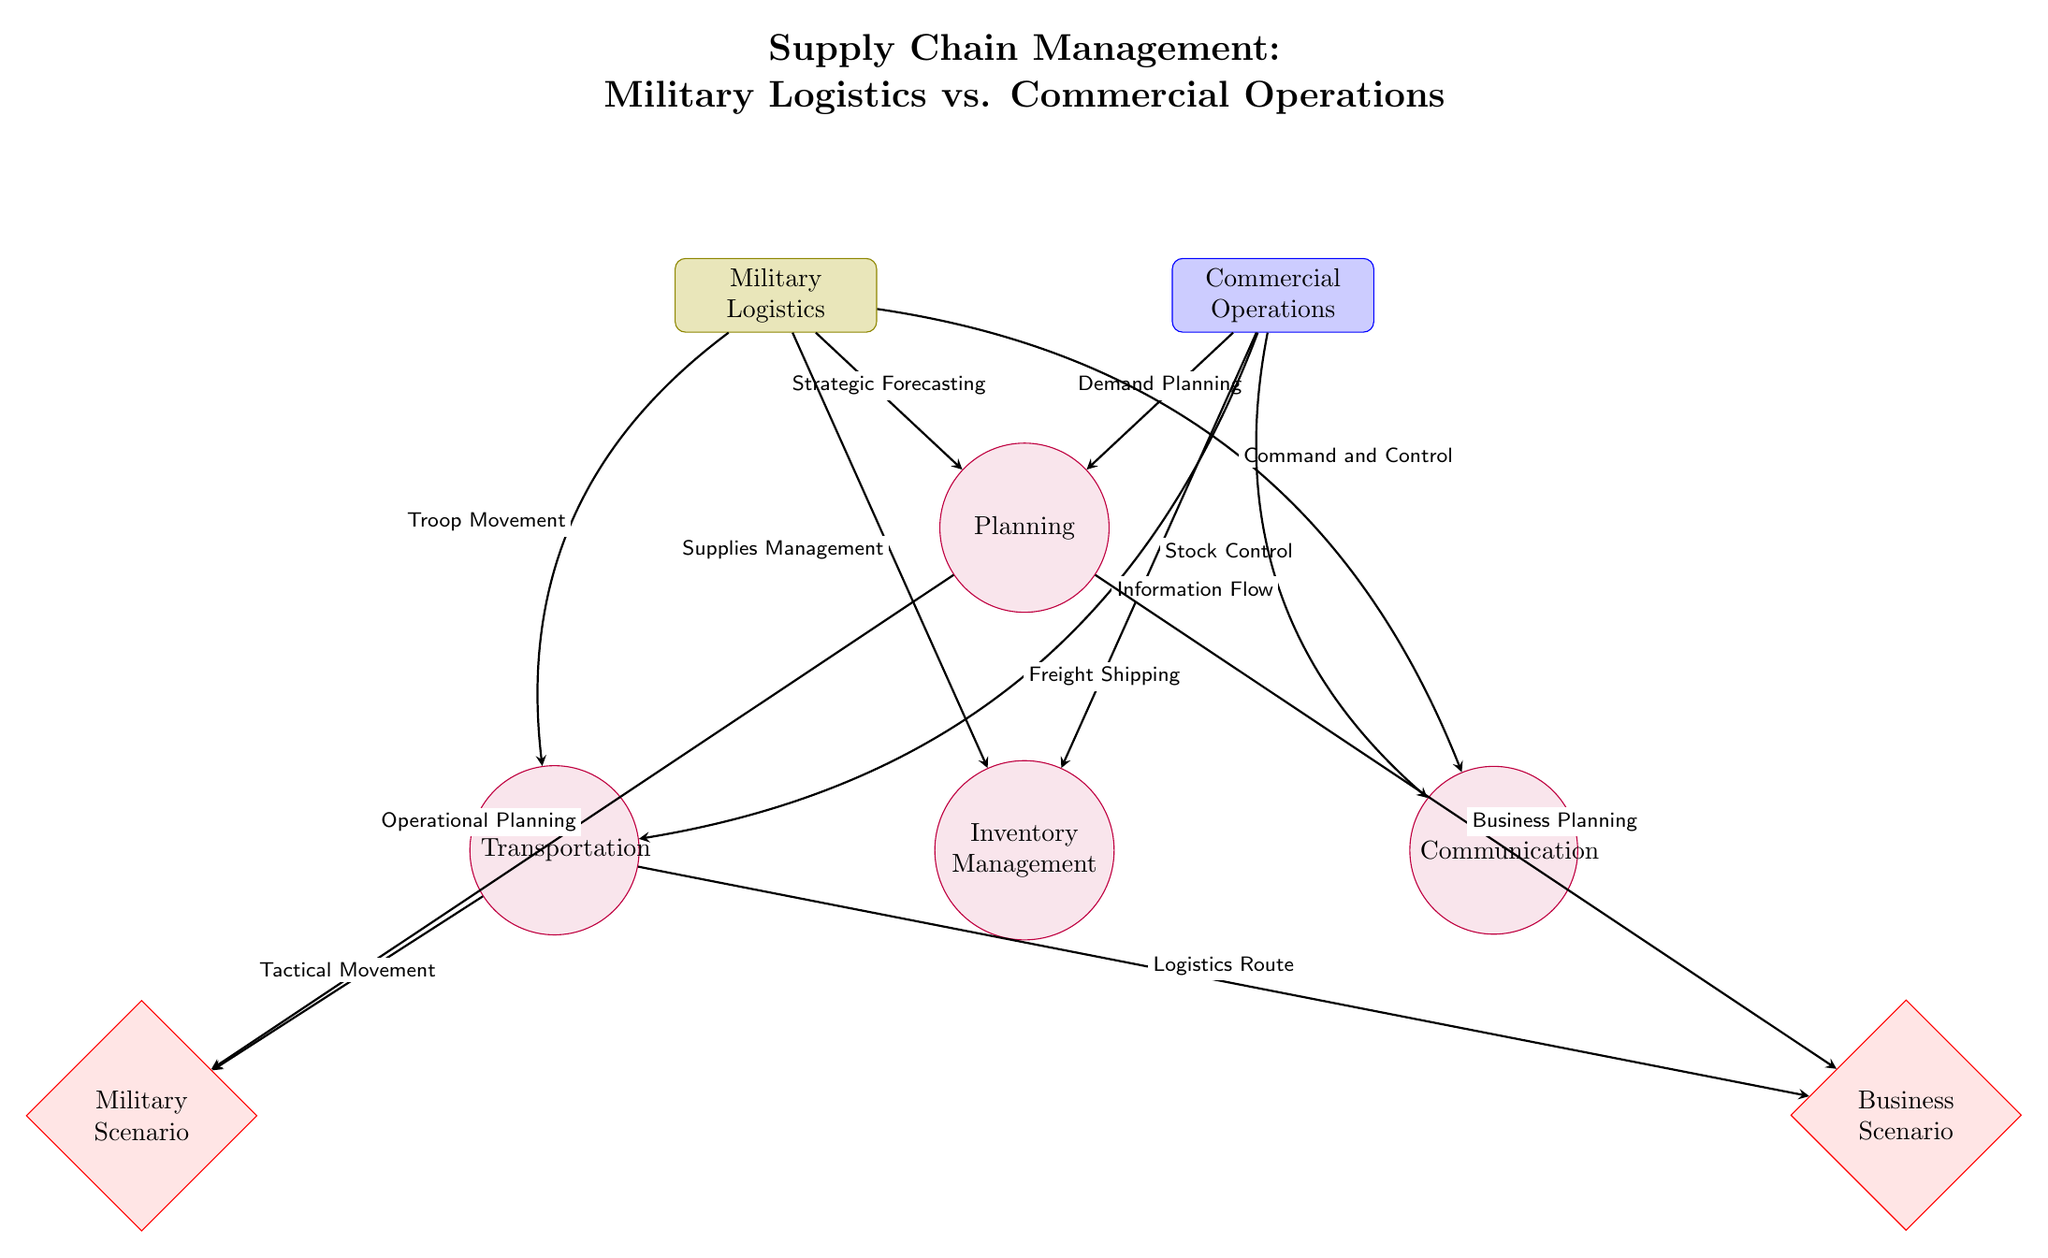What are the two main categories depicted in the diagram? The diagram shows two main categories: Military Logistics and Commercial Operations, clearly indicated at the top of the diagram.
Answer: Military Logistics, Commercial Operations Which process is directly linked to 'Command and Control'? The 'Command and Control' node is directly connected to the 'Communication' process, as represented by the arrow showing the relationship.
Answer: Communication How many total processes are represented in the diagram? The diagram illustrates four processes: Planning, Inventory Management, Transportation, and Communication, counting each distinct node in the lower section.
Answer: Four What type of planning is associated with 'Military Scenario'? The 'Military Scenario' is linked to the 'Operational Planning' which comes from the 'Planning' process as indicated by the respective arrow.
Answer: Operational Planning Which military term corresponds to the 'Transportation' process? The diagram shows that 'Troop Movement' corresponds to the 'Transportation' process, indicated by the link connecting them.
Answer: Troop Movement What is the flow direction of communication in commercial operations? The arrow for 'Information Flow' indicates that the communication flows from 'Commercial Operations' to 'Communication', demonstrating its direction.
Answer: From Commercial Operations to Communication What element shows the connection between military and commercial logistics? The 'Transportation' and 'Communication' processes are key elements showing how both military and commercial logistics connect through specific terms.
Answer: Transportation, Communication What scenario relates to 'Inventory Management' from military logistics? The 'Military Scenario' is associated with 'Inventory Management' through the 'Planning' process that feeds into it, evident from the arrows leading downwards in the diagram.
Answer: Military Scenario 